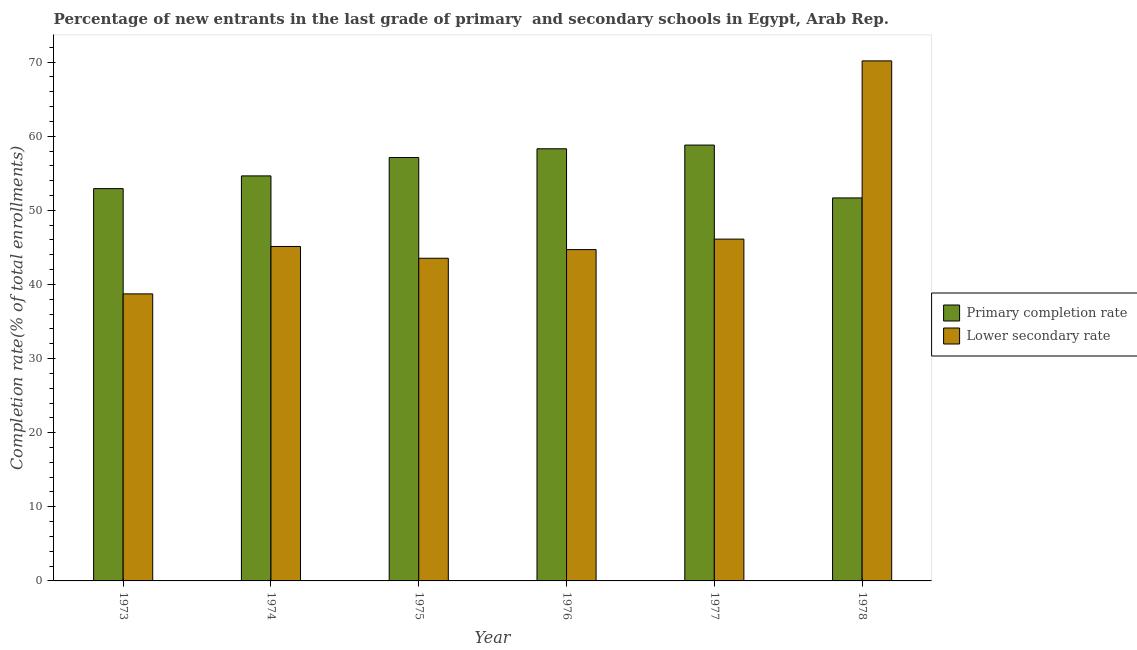How many different coloured bars are there?
Give a very brief answer. 2. Are the number of bars per tick equal to the number of legend labels?
Provide a short and direct response. Yes. How many bars are there on the 1st tick from the right?
Your answer should be compact. 2. What is the label of the 5th group of bars from the left?
Your answer should be compact. 1977. In how many cases, is the number of bars for a given year not equal to the number of legend labels?
Keep it short and to the point. 0. What is the completion rate in secondary schools in 1975?
Provide a short and direct response. 43.53. Across all years, what is the maximum completion rate in primary schools?
Your response must be concise. 58.81. Across all years, what is the minimum completion rate in secondary schools?
Offer a terse response. 38.73. In which year was the completion rate in primary schools minimum?
Give a very brief answer. 1978. What is the total completion rate in primary schools in the graph?
Your answer should be very brief. 333.48. What is the difference between the completion rate in primary schools in 1975 and that in 1978?
Your response must be concise. 5.45. What is the difference between the completion rate in primary schools in 1973 and the completion rate in secondary schools in 1974?
Your answer should be very brief. -1.72. What is the average completion rate in secondary schools per year?
Make the answer very short. 48.06. In the year 1975, what is the difference between the completion rate in secondary schools and completion rate in primary schools?
Provide a short and direct response. 0. What is the ratio of the completion rate in primary schools in 1976 to that in 1977?
Keep it short and to the point. 0.99. Is the completion rate in primary schools in 1977 less than that in 1978?
Keep it short and to the point. No. Is the difference between the completion rate in secondary schools in 1975 and 1976 greater than the difference between the completion rate in primary schools in 1975 and 1976?
Give a very brief answer. No. What is the difference between the highest and the second highest completion rate in secondary schools?
Give a very brief answer. 24.05. What is the difference between the highest and the lowest completion rate in secondary schools?
Ensure brevity in your answer.  31.44. What does the 2nd bar from the left in 1976 represents?
Offer a terse response. Lower secondary rate. What does the 2nd bar from the right in 1977 represents?
Your answer should be very brief. Primary completion rate. How many bars are there?
Your answer should be compact. 12. Are all the bars in the graph horizontal?
Give a very brief answer. No. Does the graph contain grids?
Keep it short and to the point. No. How many legend labels are there?
Provide a succinct answer. 2. How are the legend labels stacked?
Your answer should be very brief. Vertical. What is the title of the graph?
Your response must be concise. Percentage of new entrants in the last grade of primary  and secondary schools in Egypt, Arab Rep. Does "Under-5(female)" appear as one of the legend labels in the graph?
Provide a short and direct response. No. What is the label or title of the Y-axis?
Your answer should be very brief. Completion rate(% of total enrollments). What is the Completion rate(% of total enrollments) in Primary completion rate in 1973?
Keep it short and to the point. 52.93. What is the Completion rate(% of total enrollments) in Lower secondary rate in 1973?
Your response must be concise. 38.73. What is the Completion rate(% of total enrollments) in Primary completion rate in 1974?
Offer a very short reply. 54.65. What is the Completion rate(% of total enrollments) of Lower secondary rate in 1974?
Your answer should be compact. 45.12. What is the Completion rate(% of total enrollments) in Primary completion rate in 1975?
Offer a terse response. 57.12. What is the Completion rate(% of total enrollments) of Lower secondary rate in 1975?
Offer a terse response. 43.53. What is the Completion rate(% of total enrollments) of Primary completion rate in 1976?
Offer a terse response. 58.31. What is the Completion rate(% of total enrollments) of Lower secondary rate in 1976?
Keep it short and to the point. 44.7. What is the Completion rate(% of total enrollments) in Primary completion rate in 1977?
Make the answer very short. 58.81. What is the Completion rate(% of total enrollments) in Lower secondary rate in 1977?
Your answer should be compact. 46.12. What is the Completion rate(% of total enrollments) of Primary completion rate in 1978?
Your answer should be compact. 51.67. What is the Completion rate(% of total enrollments) of Lower secondary rate in 1978?
Offer a terse response. 70.17. Across all years, what is the maximum Completion rate(% of total enrollments) of Primary completion rate?
Offer a terse response. 58.81. Across all years, what is the maximum Completion rate(% of total enrollments) in Lower secondary rate?
Make the answer very short. 70.17. Across all years, what is the minimum Completion rate(% of total enrollments) of Primary completion rate?
Your response must be concise. 51.67. Across all years, what is the minimum Completion rate(% of total enrollments) in Lower secondary rate?
Provide a short and direct response. 38.73. What is the total Completion rate(% of total enrollments) in Primary completion rate in the graph?
Keep it short and to the point. 333.48. What is the total Completion rate(% of total enrollments) in Lower secondary rate in the graph?
Ensure brevity in your answer.  288.37. What is the difference between the Completion rate(% of total enrollments) in Primary completion rate in 1973 and that in 1974?
Provide a short and direct response. -1.72. What is the difference between the Completion rate(% of total enrollments) of Lower secondary rate in 1973 and that in 1974?
Offer a terse response. -6.39. What is the difference between the Completion rate(% of total enrollments) of Primary completion rate in 1973 and that in 1975?
Offer a very short reply. -4.19. What is the difference between the Completion rate(% of total enrollments) of Lower secondary rate in 1973 and that in 1975?
Make the answer very short. -4.81. What is the difference between the Completion rate(% of total enrollments) of Primary completion rate in 1973 and that in 1976?
Provide a short and direct response. -5.38. What is the difference between the Completion rate(% of total enrollments) of Lower secondary rate in 1973 and that in 1976?
Your response must be concise. -5.98. What is the difference between the Completion rate(% of total enrollments) of Primary completion rate in 1973 and that in 1977?
Offer a very short reply. -5.88. What is the difference between the Completion rate(% of total enrollments) in Lower secondary rate in 1973 and that in 1977?
Your response must be concise. -7.39. What is the difference between the Completion rate(% of total enrollments) in Primary completion rate in 1973 and that in 1978?
Ensure brevity in your answer.  1.26. What is the difference between the Completion rate(% of total enrollments) of Lower secondary rate in 1973 and that in 1978?
Offer a terse response. -31.44. What is the difference between the Completion rate(% of total enrollments) of Primary completion rate in 1974 and that in 1975?
Provide a succinct answer. -2.48. What is the difference between the Completion rate(% of total enrollments) in Lower secondary rate in 1974 and that in 1975?
Make the answer very short. 1.59. What is the difference between the Completion rate(% of total enrollments) in Primary completion rate in 1974 and that in 1976?
Your response must be concise. -3.66. What is the difference between the Completion rate(% of total enrollments) in Lower secondary rate in 1974 and that in 1976?
Make the answer very short. 0.42. What is the difference between the Completion rate(% of total enrollments) of Primary completion rate in 1974 and that in 1977?
Keep it short and to the point. -4.16. What is the difference between the Completion rate(% of total enrollments) of Lower secondary rate in 1974 and that in 1977?
Your response must be concise. -0.99. What is the difference between the Completion rate(% of total enrollments) of Primary completion rate in 1974 and that in 1978?
Give a very brief answer. 2.97. What is the difference between the Completion rate(% of total enrollments) in Lower secondary rate in 1974 and that in 1978?
Offer a terse response. -25.04. What is the difference between the Completion rate(% of total enrollments) in Primary completion rate in 1975 and that in 1976?
Keep it short and to the point. -1.18. What is the difference between the Completion rate(% of total enrollments) in Lower secondary rate in 1975 and that in 1976?
Provide a short and direct response. -1.17. What is the difference between the Completion rate(% of total enrollments) in Primary completion rate in 1975 and that in 1977?
Your answer should be compact. -1.68. What is the difference between the Completion rate(% of total enrollments) of Lower secondary rate in 1975 and that in 1977?
Give a very brief answer. -2.58. What is the difference between the Completion rate(% of total enrollments) of Primary completion rate in 1975 and that in 1978?
Your answer should be compact. 5.45. What is the difference between the Completion rate(% of total enrollments) in Lower secondary rate in 1975 and that in 1978?
Your answer should be very brief. -26.63. What is the difference between the Completion rate(% of total enrollments) of Primary completion rate in 1976 and that in 1977?
Offer a very short reply. -0.5. What is the difference between the Completion rate(% of total enrollments) in Lower secondary rate in 1976 and that in 1977?
Provide a succinct answer. -1.41. What is the difference between the Completion rate(% of total enrollments) in Primary completion rate in 1976 and that in 1978?
Make the answer very short. 6.63. What is the difference between the Completion rate(% of total enrollments) of Lower secondary rate in 1976 and that in 1978?
Keep it short and to the point. -25.46. What is the difference between the Completion rate(% of total enrollments) of Primary completion rate in 1977 and that in 1978?
Keep it short and to the point. 7.13. What is the difference between the Completion rate(% of total enrollments) of Lower secondary rate in 1977 and that in 1978?
Ensure brevity in your answer.  -24.05. What is the difference between the Completion rate(% of total enrollments) in Primary completion rate in 1973 and the Completion rate(% of total enrollments) in Lower secondary rate in 1974?
Ensure brevity in your answer.  7.81. What is the difference between the Completion rate(% of total enrollments) of Primary completion rate in 1973 and the Completion rate(% of total enrollments) of Lower secondary rate in 1975?
Offer a terse response. 9.4. What is the difference between the Completion rate(% of total enrollments) of Primary completion rate in 1973 and the Completion rate(% of total enrollments) of Lower secondary rate in 1976?
Provide a succinct answer. 8.23. What is the difference between the Completion rate(% of total enrollments) in Primary completion rate in 1973 and the Completion rate(% of total enrollments) in Lower secondary rate in 1977?
Give a very brief answer. 6.81. What is the difference between the Completion rate(% of total enrollments) of Primary completion rate in 1973 and the Completion rate(% of total enrollments) of Lower secondary rate in 1978?
Keep it short and to the point. -17.23. What is the difference between the Completion rate(% of total enrollments) in Primary completion rate in 1974 and the Completion rate(% of total enrollments) in Lower secondary rate in 1975?
Give a very brief answer. 11.11. What is the difference between the Completion rate(% of total enrollments) in Primary completion rate in 1974 and the Completion rate(% of total enrollments) in Lower secondary rate in 1976?
Your response must be concise. 9.94. What is the difference between the Completion rate(% of total enrollments) of Primary completion rate in 1974 and the Completion rate(% of total enrollments) of Lower secondary rate in 1977?
Your response must be concise. 8.53. What is the difference between the Completion rate(% of total enrollments) in Primary completion rate in 1974 and the Completion rate(% of total enrollments) in Lower secondary rate in 1978?
Provide a succinct answer. -15.52. What is the difference between the Completion rate(% of total enrollments) of Primary completion rate in 1975 and the Completion rate(% of total enrollments) of Lower secondary rate in 1976?
Offer a very short reply. 12.42. What is the difference between the Completion rate(% of total enrollments) in Primary completion rate in 1975 and the Completion rate(% of total enrollments) in Lower secondary rate in 1977?
Give a very brief answer. 11.01. What is the difference between the Completion rate(% of total enrollments) of Primary completion rate in 1975 and the Completion rate(% of total enrollments) of Lower secondary rate in 1978?
Your answer should be compact. -13.04. What is the difference between the Completion rate(% of total enrollments) in Primary completion rate in 1976 and the Completion rate(% of total enrollments) in Lower secondary rate in 1977?
Ensure brevity in your answer.  12.19. What is the difference between the Completion rate(% of total enrollments) in Primary completion rate in 1976 and the Completion rate(% of total enrollments) in Lower secondary rate in 1978?
Keep it short and to the point. -11.86. What is the difference between the Completion rate(% of total enrollments) in Primary completion rate in 1977 and the Completion rate(% of total enrollments) in Lower secondary rate in 1978?
Your response must be concise. -11.36. What is the average Completion rate(% of total enrollments) of Primary completion rate per year?
Offer a very short reply. 55.58. What is the average Completion rate(% of total enrollments) of Lower secondary rate per year?
Your answer should be very brief. 48.06. In the year 1973, what is the difference between the Completion rate(% of total enrollments) of Primary completion rate and Completion rate(% of total enrollments) of Lower secondary rate?
Your response must be concise. 14.2. In the year 1974, what is the difference between the Completion rate(% of total enrollments) in Primary completion rate and Completion rate(% of total enrollments) in Lower secondary rate?
Your answer should be very brief. 9.52. In the year 1975, what is the difference between the Completion rate(% of total enrollments) of Primary completion rate and Completion rate(% of total enrollments) of Lower secondary rate?
Make the answer very short. 13.59. In the year 1976, what is the difference between the Completion rate(% of total enrollments) of Primary completion rate and Completion rate(% of total enrollments) of Lower secondary rate?
Offer a terse response. 13.6. In the year 1977, what is the difference between the Completion rate(% of total enrollments) of Primary completion rate and Completion rate(% of total enrollments) of Lower secondary rate?
Make the answer very short. 12.69. In the year 1978, what is the difference between the Completion rate(% of total enrollments) in Primary completion rate and Completion rate(% of total enrollments) in Lower secondary rate?
Provide a succinct answer. -18.49. What is the ratio of the Completion rate(% of total enrollments) of Primary completion rate in 1973 to that in 1974?
Give a very brief answer. 0.97. What is the ratio of the Completion rate(% of total enrollments) of Lower secondary rate in 1973 to that in 1974?
Provide a succinct answer. 0.86. What is the ratio of the Completion rate(% of total enrollments) of Primary completion rate in 1973 to that in 1975?
Make the answer very short. 0.93. What is the ratio of the Completion rate(% of total enrollments) of Lower secondary rate in 1973 to that in 1975?
Keep it short and to the point. 0.89. What is the ratio of the Completion rate(% of total enrollments) in Primary completion rate in 1973 to that in 1976?
Offer a very short reply. 0.91. What is the ratio of the Completion rate(% of total enrollments) of Lower secondary rate in 1973 to that in 1976?
Your response must be concise. 0.87. What is the ratio of the Completion rate(% of total enrollments) of Primary completion rate in 1973 to that in 1977?
Provide a short and direct response. 0.9. What is the ratio of the Completion rate(% of total enrollments) in Lower secondary rate in 1973 to that in 1977?
Ensure brevity in your answer.  0.84. What is the ratio of the Completion rate(% of total enrollments) in Primary completion rate in 1973 to that in 1978?
Your response must be concise. 1.02. What is the ratio of the Completion rate(% of total enrollments) in Lower secondary rate in 1973 to that in 1978?
Offer a terse response. 0.55. What is the ratio of the Completion rate(% of total enrollments) of Primary completion rate in 1974 to that in 1975?
Keep it short and to the point. 0.96. What is the ratio of the Completion rate(% of total enrollments) in Lower secondary rate in 1974 to that in 1975?
Your response must be concise. 1.04. What is the ratio of the Completion rate(% of total enrollments) of Primary completion rate in 1974 to that in 1976?
Offer a terse response. 0.94. What is the ratio of the Completion rate(% of total enrollments) of Lower secondary rate in 1974 to that in 1976?
Give a very brief answer. 1.01. What is the ratio of the Completion rate(% of total enrollments) of Primary completion rate in 1974 to that in 1977?
Make the answer very short. 0.93. What is the ratio of the Completion rate(% of total enrollments) in Lower secondary rate in 1974 to that in 1977?
Offer a very short reply. 0.98. What is the ratio of the Completion rate(% of total enrollments) in Primary completion rate in 1974 to that in 1978?
Ensure brevity in your answer.  1.06. What is the ratio of the Completion rate(% of total enrollments) of Lower secondary rate in 1974 to that in 1978?
Your answer should be very brief. 0.64. What is the ratio of the Completion rate(% of total enrollments) in Primary completion rate in 1975 to that in 1976?
Provide a short and direct response. 0.98. What is the ratio of the Completion rate(% of total enrollments) of Lower secondary rate in 1975 to that in 1976?
Your answer should be very brief. 0.97. What is the ratio of the Completion rate(% of total enrollments) of Primary completion rate in 1975 to that in 1977?
Provide a short and direct response. 0.97. What is the ratio of the Completion rate(% of total enrollments) in Lower secondary rate in 1975 to that in 1977?
Offer a terse response. 0.94. What is the ratio of the Completion rate(% of total enrollments) in Primary completion rate in 1975 to that in 1978?
Offer a very short reply. 1.11. What is the ratio of the Completion rate(% of total enrollments) in Lower secondary rate in 1975 to that in 1978?
Your response must be concise. 0.62. What is the ratio of the Completion rate(% of total enrollments) in Primary completion rate in 1976 to that in 1977?
Your answer should be compact. 0.99. What is the ratio of the Completion rate(% of total enrollments) of Lower secondary rate in 1976 to that in 1977?
Provide a short and direct response. 0.97. What is the ratio of the Completion rate(% of total enrollments) in Primary completion rate in 1976 to that in 1978?
Offer a very short reply. 1.13. What is the ratio of the Completion rate(% of total enrollments) in Lower secondary rate in 1976 to that in 1978?
Your response must be concise. 0.64. What is the ratio of the Completion rate(% of total enrollments) in Primary completion rate in 1977 to that in 1978?
Your response must be concise. 1.14. What is the ratio of the Completion rate(% of total enrollments) in Lower secondary rate in 1977 to that in 1978?
Provide a succinct answer. 0.66. What is the difference between the highest and the second highest Completion rate(% of total enrollments) of Primary completion rate?
Your answer should be very brief. 0.5. What is the difference between the highest and the second highest Completion rate(% of total enrollments) in Lower secondary rate?
Offer a terse response. 24.05. What is the difference between the highest and the lowest Completion rate(% of total enrollments) in Primary completion rate?
Provide a short and direct response. 7.13. What is the difference between the highest and the lowest Completion rate(% of total enrollments) in Lower secondary rate?
Provide a succinct answer. 31.44. 